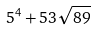<formula> <loc_0><loc_0><loc_500><loc_500>5 ^ { 4 } + 5 3 \sqrt { 8 9 }</formula> 